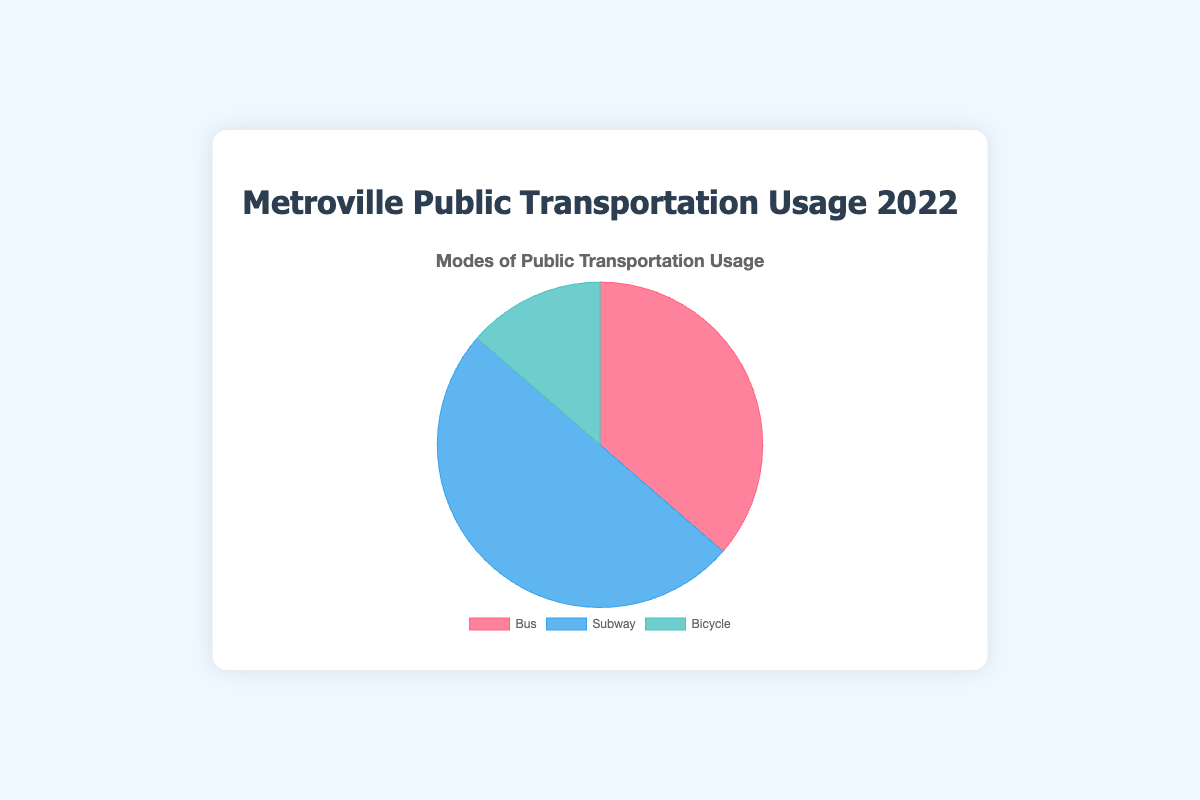What percentage of total users used the Bus? To find the percentage of users who used the Bus, divide the number of Bus users by the total number of users, then multiply by 100. So, (400,000 / 1,100,000) * 100 = 36.36%.
Answer: 36.36% Which mode of public transportation had the highest number of users? Looking at the user numbers, the Subway had 550,000 users, which is higher than both the Bus and Bicycle.
Answer: Subway What is the difference between the number of Subway users and Bicycle users? Subtract the number of Bicycle users from the number of Subway users: 550,000 - 150,000 = 400,000.
Answer: 400,000 How many more people used the Bus compared to the Bicycle? Subtract the number of Bicycle users from the number of Bus users: 400,000 - 150,000 = 250,000.
Answer: 250,000 What is the combined number of users for Bus and Bicycle? Add the number of Bus users to the number of Bicycle users: 400,000 + 150,000 = 550,000.
Answer: 550,000 Which mode of transportation is represented by the blue section of the pie chart? The chart's details show that the Subway section is blue.
Answer: Subway What is the combined percentage of users who used Bus and Bicycle? First, find the individual percentages: Bus (36.36%) and Bicycle (13.64%), then add them together. 36.36% + 13.64% = 50%.
Answer: 50% If the number of Subway users increased by 10%, what would the new total number of users be? A 10% increase in Subway users is 10% of 550,000, which is 55,000. Adding 55,000 to the original total number of users gives 1,100,000 + 55,000 = 1,155,000.
Answer: 1,155,000 Between which two modes of transportation is the usage most similar? Comparing the numbers, Bus uses 400,000 and Subway uses 550,000, which is a difference of 150,000. Bicycle usage is 150,000, so the usage between Bus and Subway is most similar based on overall figures.
Answer: Bus and Subway 